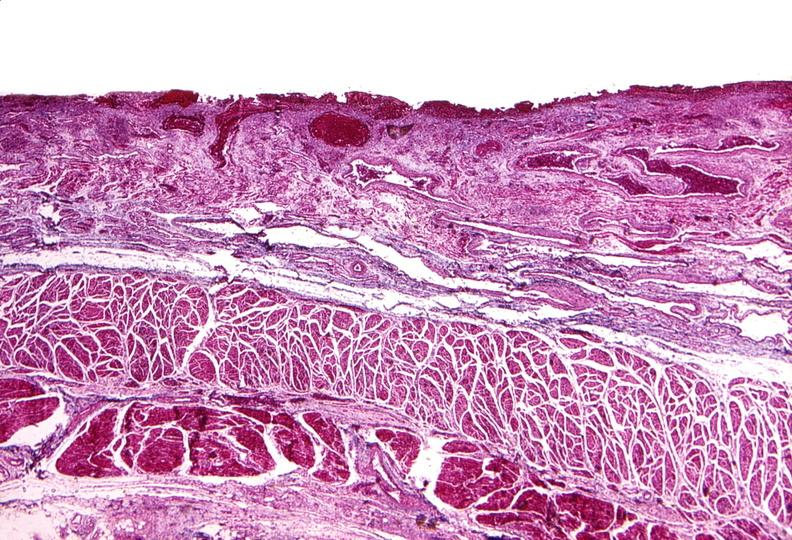s gastrointestinal present?
Answer the question using a single word or phrase. Yes 